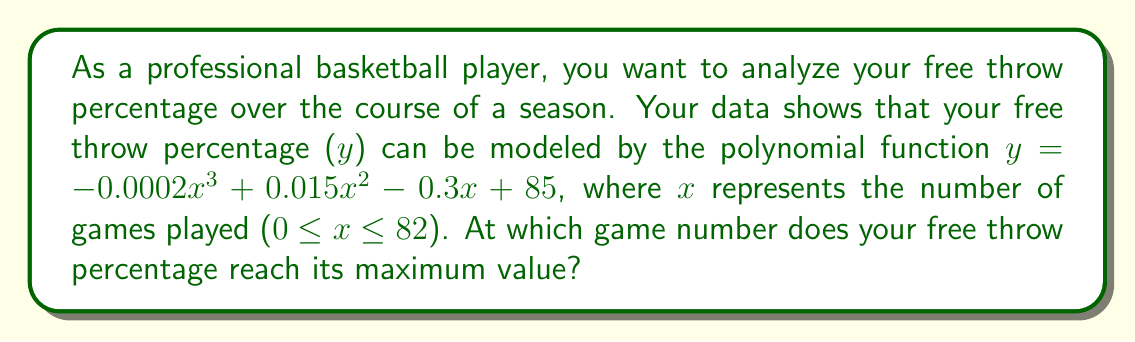Provide a solution to this math problem. To find the maximum value of the free throw percentage, we need to follow these steps:

1) First, we need to find the derivative of the function:
   $$y = -0.0002x^3 + 0.015x^2 - 0.3x + 85$$
   $$\frac{dy}{dx} = -0.0006x^2 + 0.03x - 0.3$$

2) To find the critical points, set the derivative equal to zero:
   $$-0.0006x^2 + 0.03x - 0.3 = 0$$

3) This is a quadratic equation. We can solve it using the quadratic formula:
   $$x = \frac{-b \pm \sqrt{b^2 - 4ac}}{2a}$$
   where $a = -0.0006$, $b = 0.03$, and $c = -0.3$

4) Plugging in these values:
   $$x = \frac{-0.03 \pm \sqrt{0.03^2 - 4(-0.0006)(-0.3)}}{2(-0.0006)}$$
   $$= \frac{-0.03 \pm \sqrt{0.0009 - 0.00072}}{-0.0012}$$
   $$= \frac{-0.03 \pm \sqrt{0.00018}}{-0.0012}$$
   $$= \frac{-0.03 \pm 0.0134164}{-0.0012}$$

5) This gives us two solutions:
   $$x_1 = \frac{-0.03 + 0.0134164}{-0.0012} \approx 13.82$$
   $$x_2 = \frac{-0.03 - 0.0134164}{-0.0012} \approx 36.18$$

6) To determine which of these is the maximum (rather than the minimum), we can check the second derivative:
   $$\frac{d^2y}{dx^2} = -0.0012x + 0.03$$

7) Plugging in x = 36.18:
   $$\frac{d^2y}{dx^2} = -0.0012(36.18) + 0.03 = -0.01342 < 0$$

   This negative value indicates that x = 36.18 is indeed a maximum.

8) Since we're dealing with game numbers, we need to round to the nearest integer: 36.

Therefore, the free throw percentage reaches its maximum at game number 36.
Answer: 36 